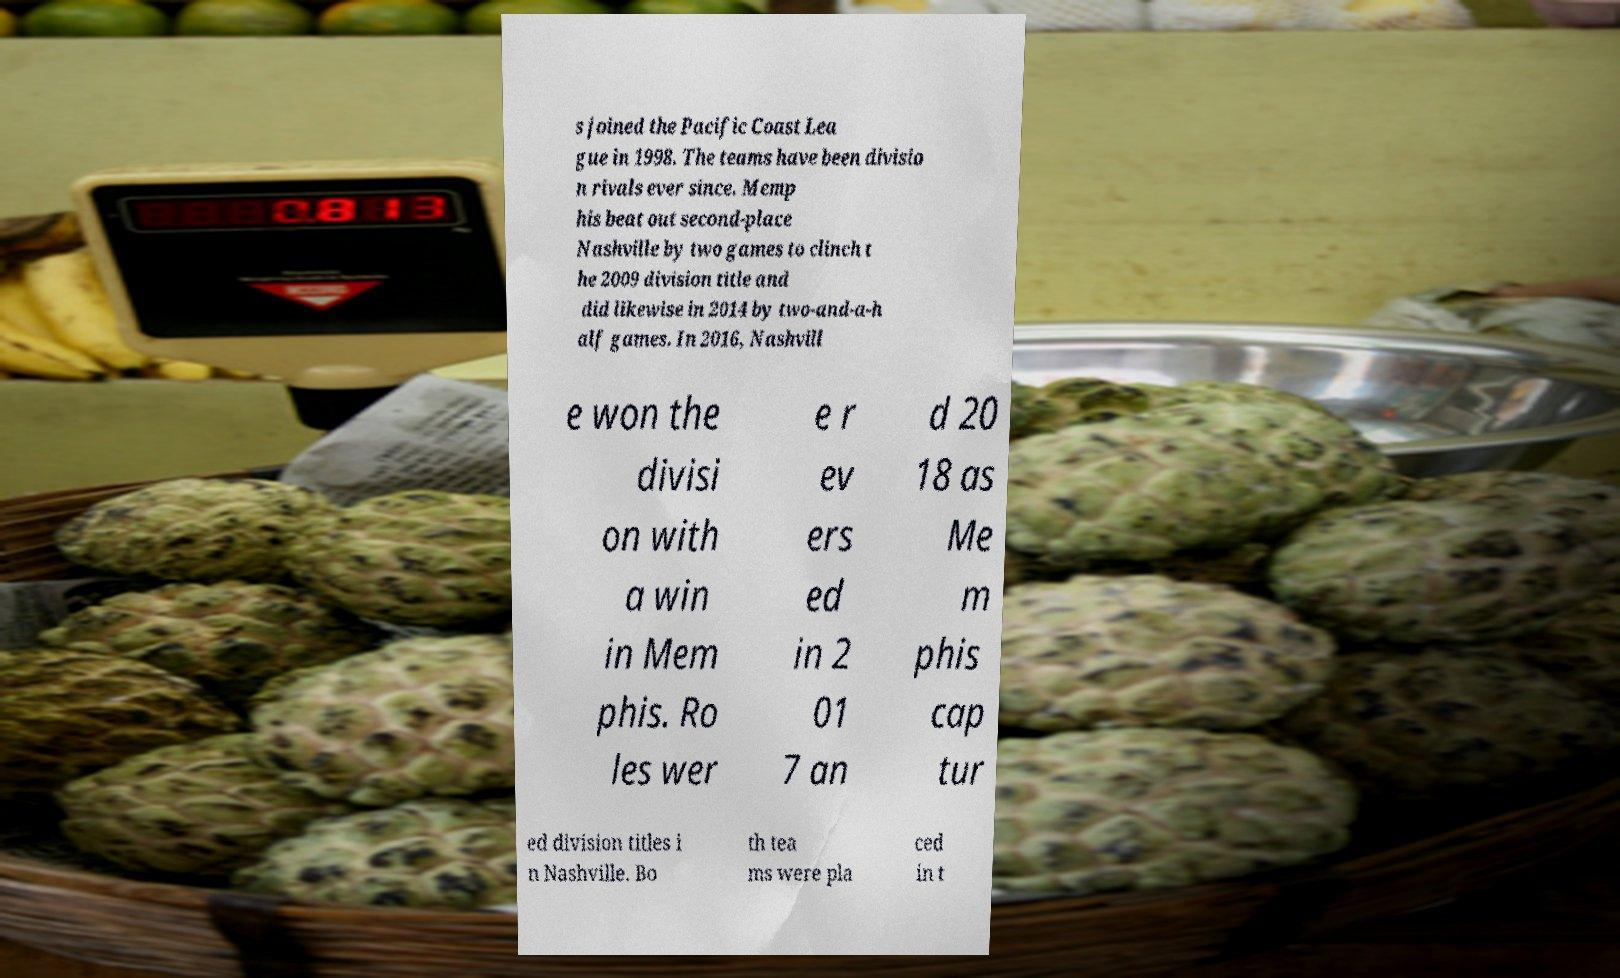Please identify and transcribe the text found in this image. s joined the Pacific Coast Lea gue in 1998. The teams have been divisio n rivals ever since. Memp his beat out second-place Nashville by two games to clinch t he 2009 division title and did likewise in 2014 by two-and-a-h alf games. In 2016, Nashvill e won the divisi on with a win in Mem phis. Ro les wer e r ev ers ed in 2 01 7 an d 20 18 as Me m phis cap tur ed division titles i n Nashville. Bo th tea ms were pla ced in t 